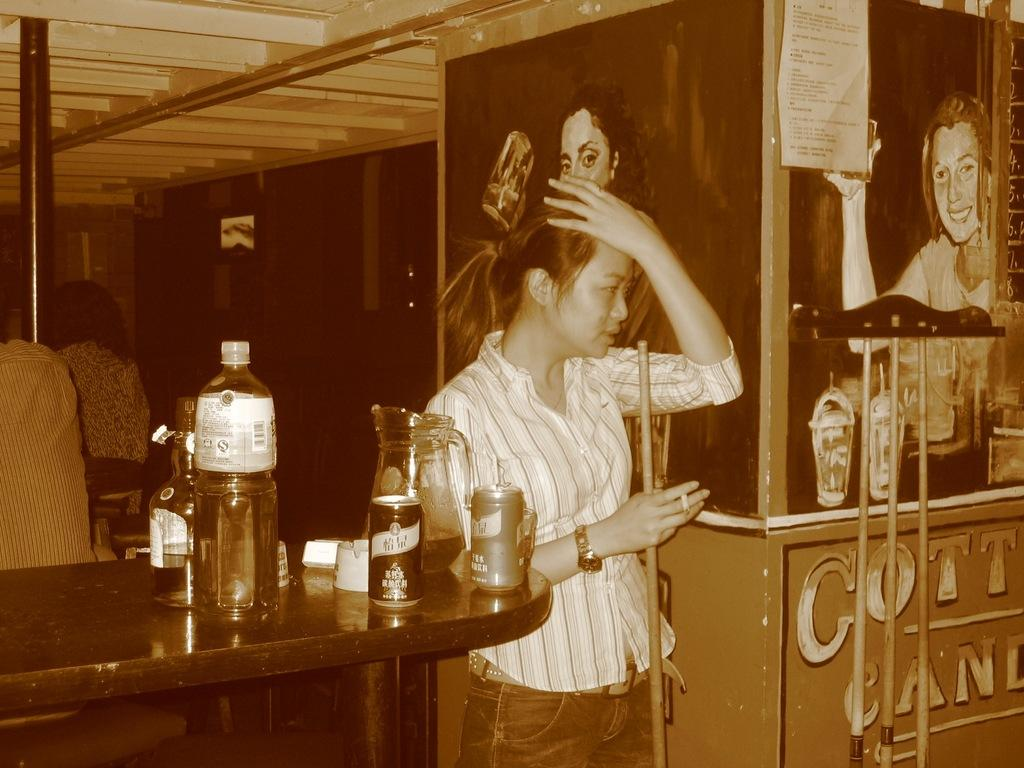Who is present in the image? There is a woman in the image. What is the woman doing in the image? The woman is standing in the image. What is the woman holding in her hand? The woman is holding a stick in her hand. What objects can be seen on the table in the image? There are bottles and cans on a table in the image. What decorations are on the wall in the image? There are posters on the wall in the image. What type of berry is being used to make the jam in the image? There is no berry or jam present in the image. What decisions is the committee making in the image? There is no committee or decision-making process depicted in the image. 